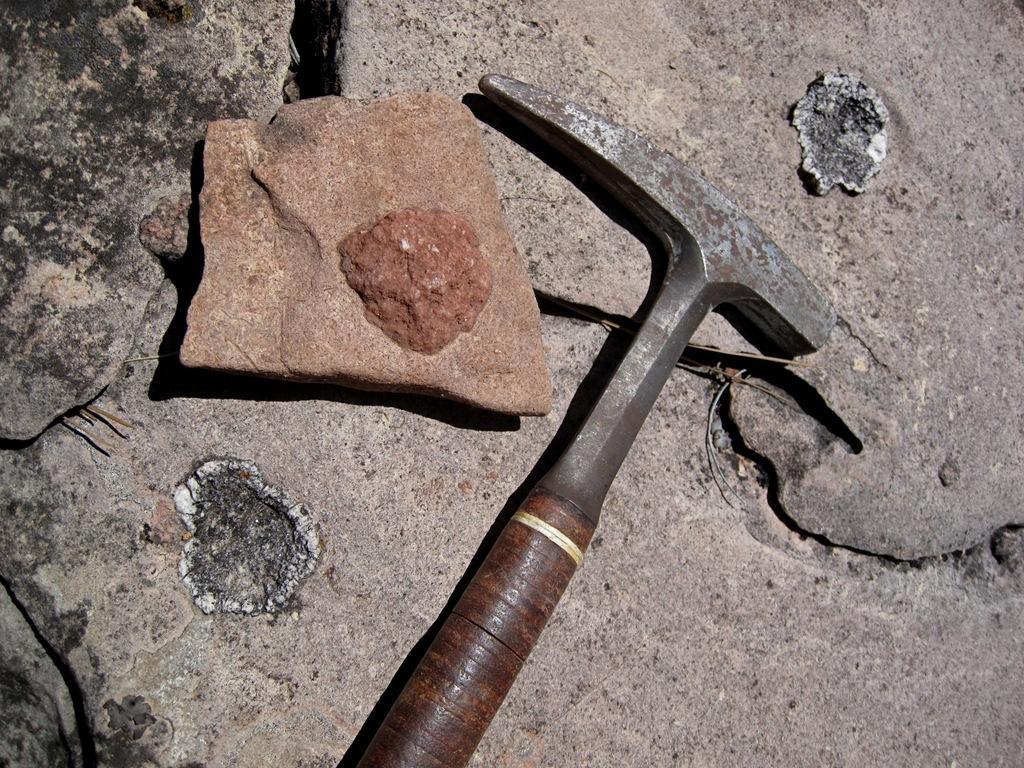Describe this image in one or two sentences. In this picture we can see a hammer which is near to the stone. 